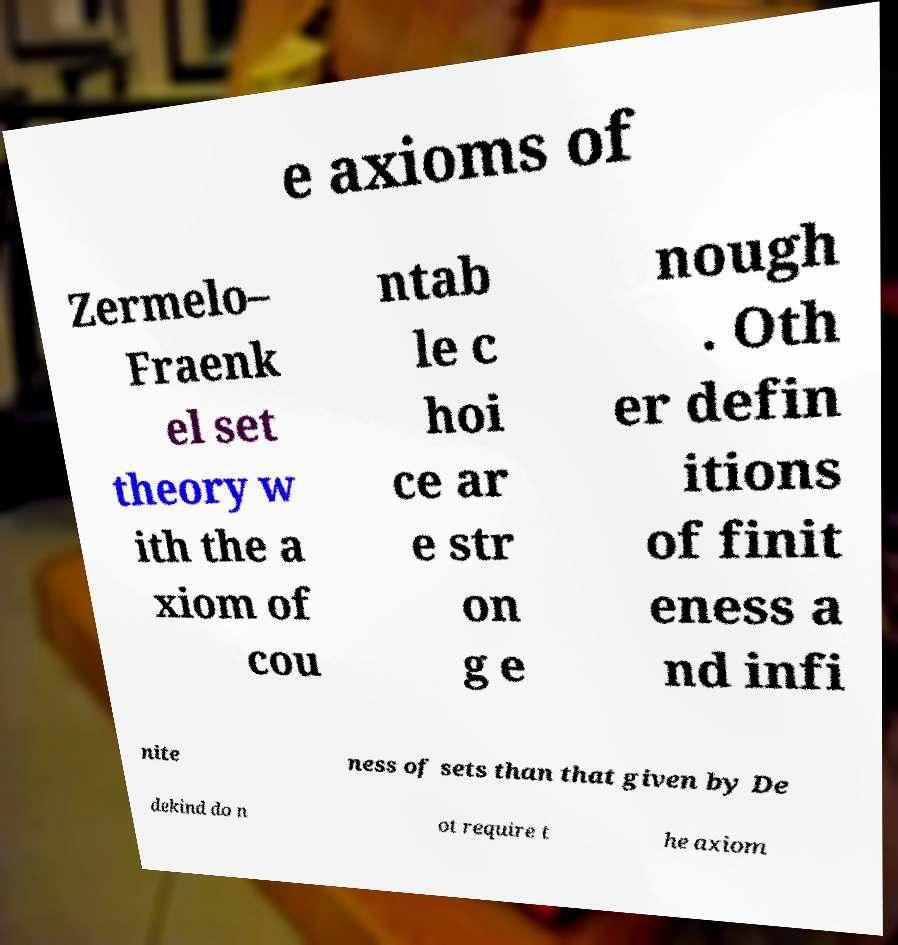Can you read and provide the text displayed in the image?This photo seems to have some interesting text. Can you extract and type it out for me? e axioms of Zermelo– Fraenk el set theory w ith the a xiom of cou ntab le c hoi ce ar e str on g e nough . Oth er defin itions of finit eness a nd infi nite ness of sets than that given by De dekind do n ot require t he axiom 